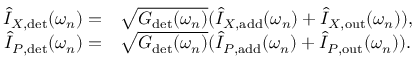<formula> <loc_0><loc_0><loc_500><loc_500>\begin{array} { r l } { \hat { I } _ { X , d e t } ( \omega _ { n } ) = } & \sqrt { G _ { d e t } ( \omega _ { n } ) } ( \hat { I } _ { X , a d d } ( \omega _ { n } ) + \hat { I } _ { X , o u t } ( \omega _ { n } ) ) , } \\ { \hat { I } _ { P , d e t } ( \omega _ { n } ) = } & \sqrt { G _ { d e t } ( \omega _ { n } ) } ( \hat { I } _ { P , a d d } ( \omega _ { n } ) + \hat { I } _ { P , o u t } ( \omega _ { n } ) ) . } \end{array}</formula> 